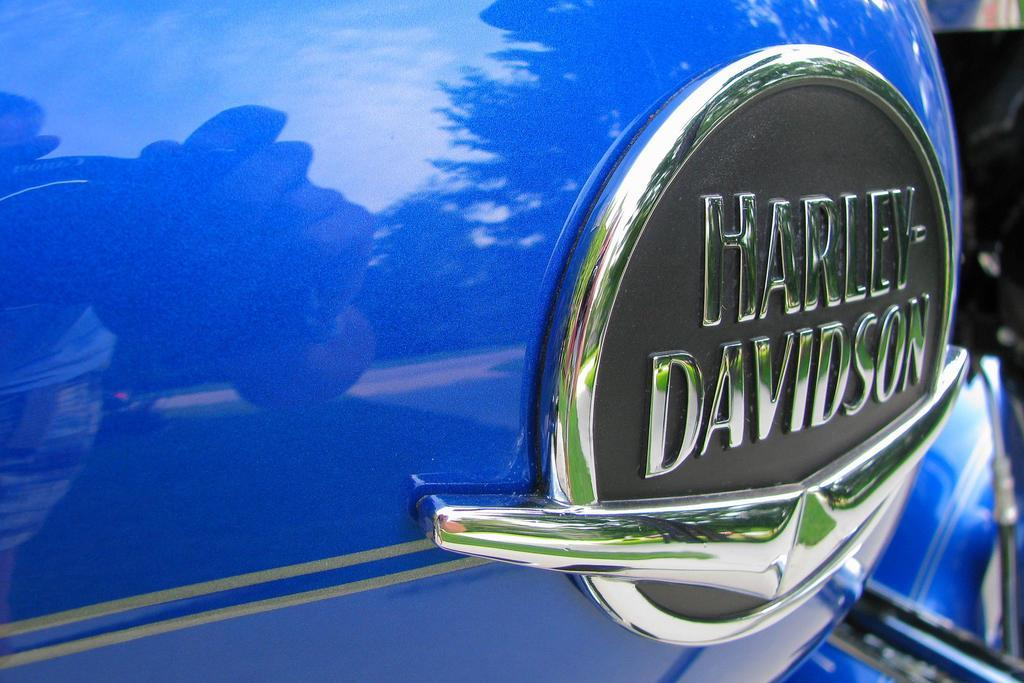What is the main subject in the center of the image? There is a vehicle in the center of the image. Can you describe any additional features of the vehicle? There is some text on the vehicle. What type of camera is your brother using to take a picture of the vehicle? There is no information about a brother or a camera in the image, so we cannot answer that question. 